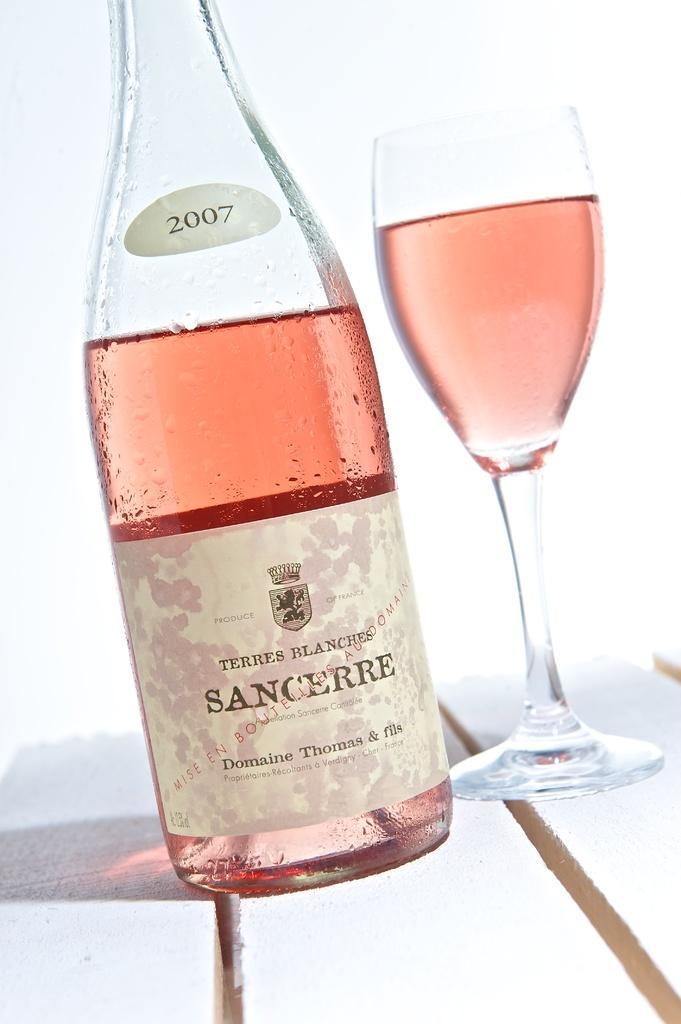Describe this image in one or two sentences. in this picture we can see that a Pink beer bottle and the glass on the top of the table and Sancheere label on it. 